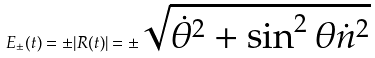Convert formula to latex. <formula><loc_0><loc_0><loc_500><loc_500>E _ { \pm } ( t ) = \pm | R ( t ) | = \pm \sqrt { \dot { \theta } ^ { 2 } + \sin ^ { 2 } \theta \dot { n } ^ { 2 } }</formula> 